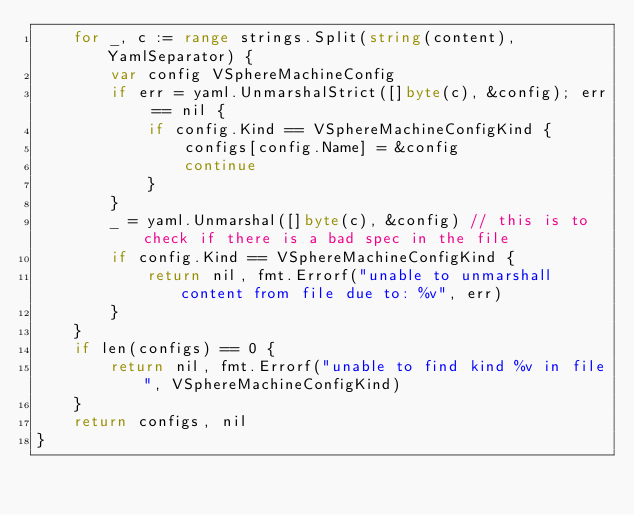<code> <loc_0><loc_0><loc_500><loc_500><_Go_>	for _, c := range strings.Split(string(content), YamlSeparator) {
		var config VSphereMachineConfig
		if err = yaml.UnmarshalStrict([]byte(c), &config); err == nil {
			if config.Kind == VSphereMachineConfigKind {
				configs[config.Name] = &config
				continue
			}
		}
		_ = yaml.Unmarshal([]byte(c), &config) // this is to check if there is a bad spec in the file
		if config.Kind == VSphereMachineConfigKind {
			return nil, fmt.Errorf("unable to unmarshall content from file due to: %v", err)
		}
	}
	if len(configs) == 0 {
		return nil, fmt.Errorf("unable to find kind %v in file", VSphereMachineConfigKind)
	}
	return configs, nil
}
</code> 